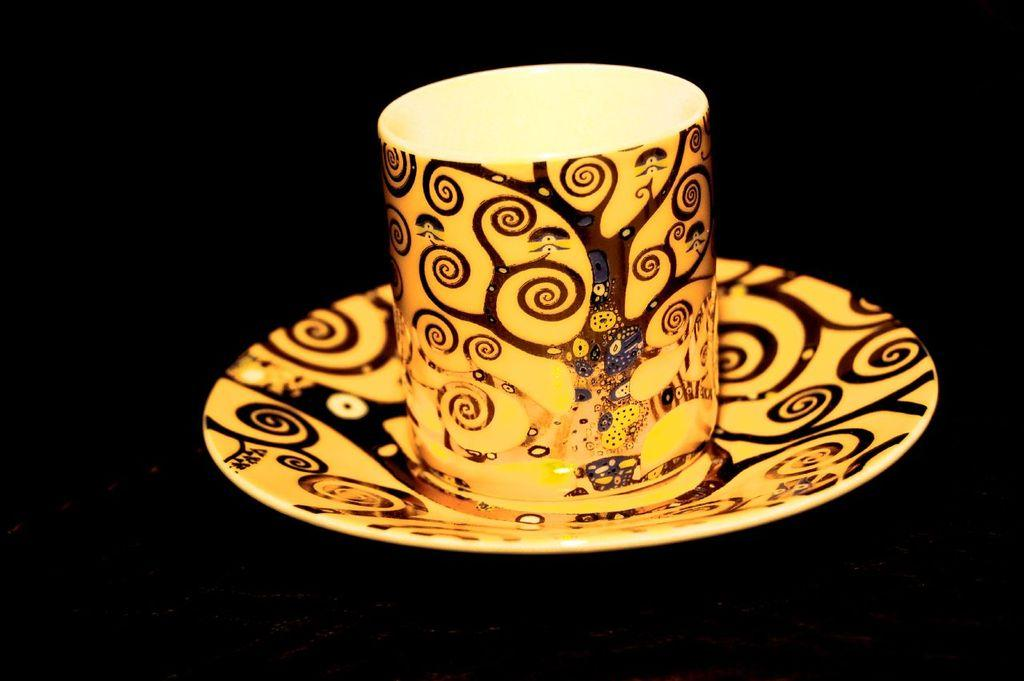What is the main subject of the image? The main subject of the image is a painting. What objects are depicted in the painting? The painting depicts a cup and saucer. What color is the background of the painting? The background of the painting is black. Can you hear the sound of the waves in the image? There is no sound or audio present in the image, as it is a static visual representation. How many children are visible in the image? There are no children present in the image; it features a painting of a cup and saucer. 